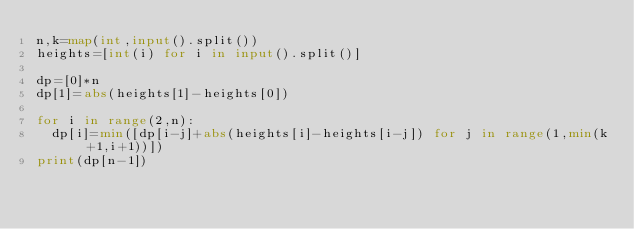<code> <loc_0><loc_0><loc_500><loc_500><_Python_>n,k=map(int,input().split())
heights=[int(i) for i in input().split()]

dp=[0]*n
dp[1]=abs(heights[1]-heights[0])

for i in range(2,n):
  dp[i]=min([dp[i-j]+abs(heights[i]-heights[i-j]) for j in range(1,min(k+1,i+1))])
print(dp[n-1])</code> 